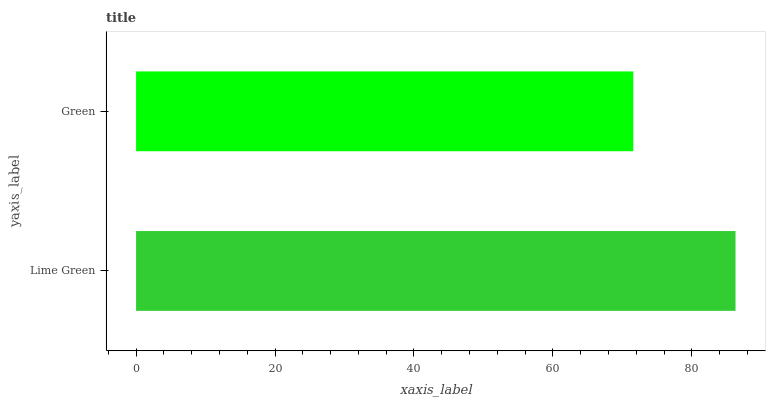Is Green the minimum?
Answer yes or no. Yes. Is Lime Green the maximum?
Answer yes or no. Yes. Is Green the maximum?
Answer yes or no. No. Is Lime Green greater than Green?
Answer yes or no. Yes. Is Green less than Lime Green?
Answer yes or no. Yes. Is Green greater than Lime Green?
Answer yes or no. No. Is Lime Green less than Green?
Answer yes or no. No. Is Lime Green the high median?
Answer yes or no. Yes. Is Green the low median?
Answer yes or no. Yes. Is Green the high median?
Answer yes or no. No. Is Lime Green the low median?
Answer yes or no. No. 